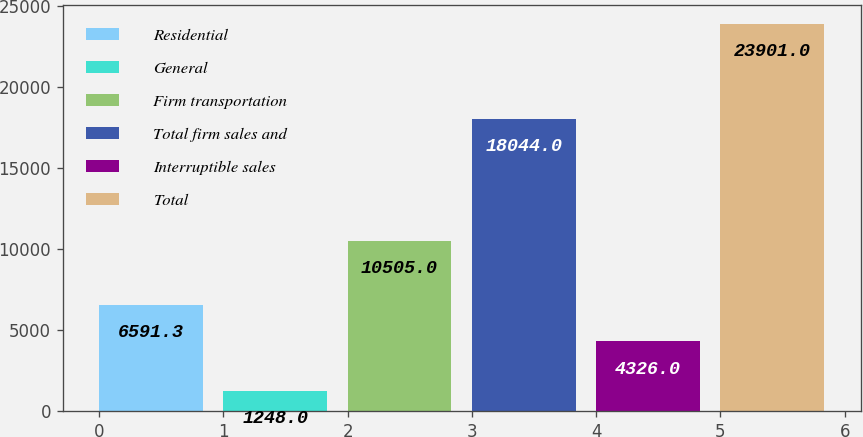Convert chart. <chart><loc_0><loc_0><loc_500><loc_500><bar_chart><fcel>Residential<fcel>General<fcel>Firm transportation<fcel>Total firm sales and<fcel>Interruptible sales<fcel>Total<nl><fcel>6591.3<fcel>1248<fcel>10505<fcel>18044<fcel>4326<fcel>23901<nl></chart> 